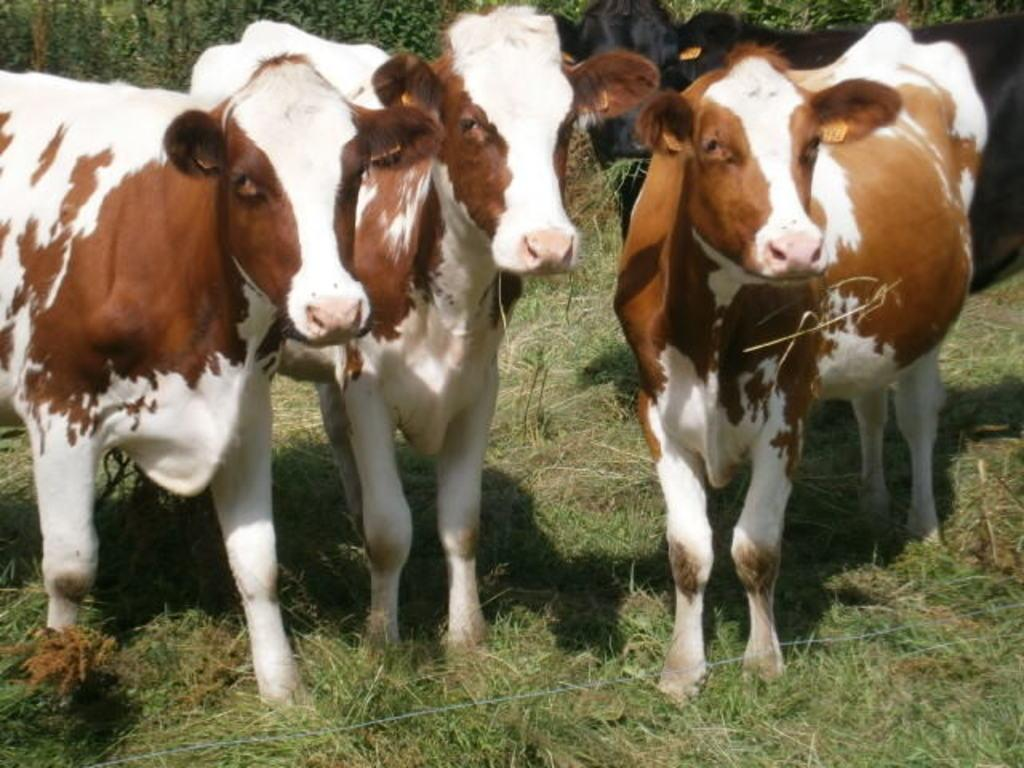What animals are present in the image? There are cows in the image. What type of vegetation is on the ground in the image? There is grass on the ground in the image. What can be seen in the background of the image? There are trees in the background of the image. How many girls are holding a dime in the image? There are no girls or dimes present in the image; it features cows, grass, and trees. 